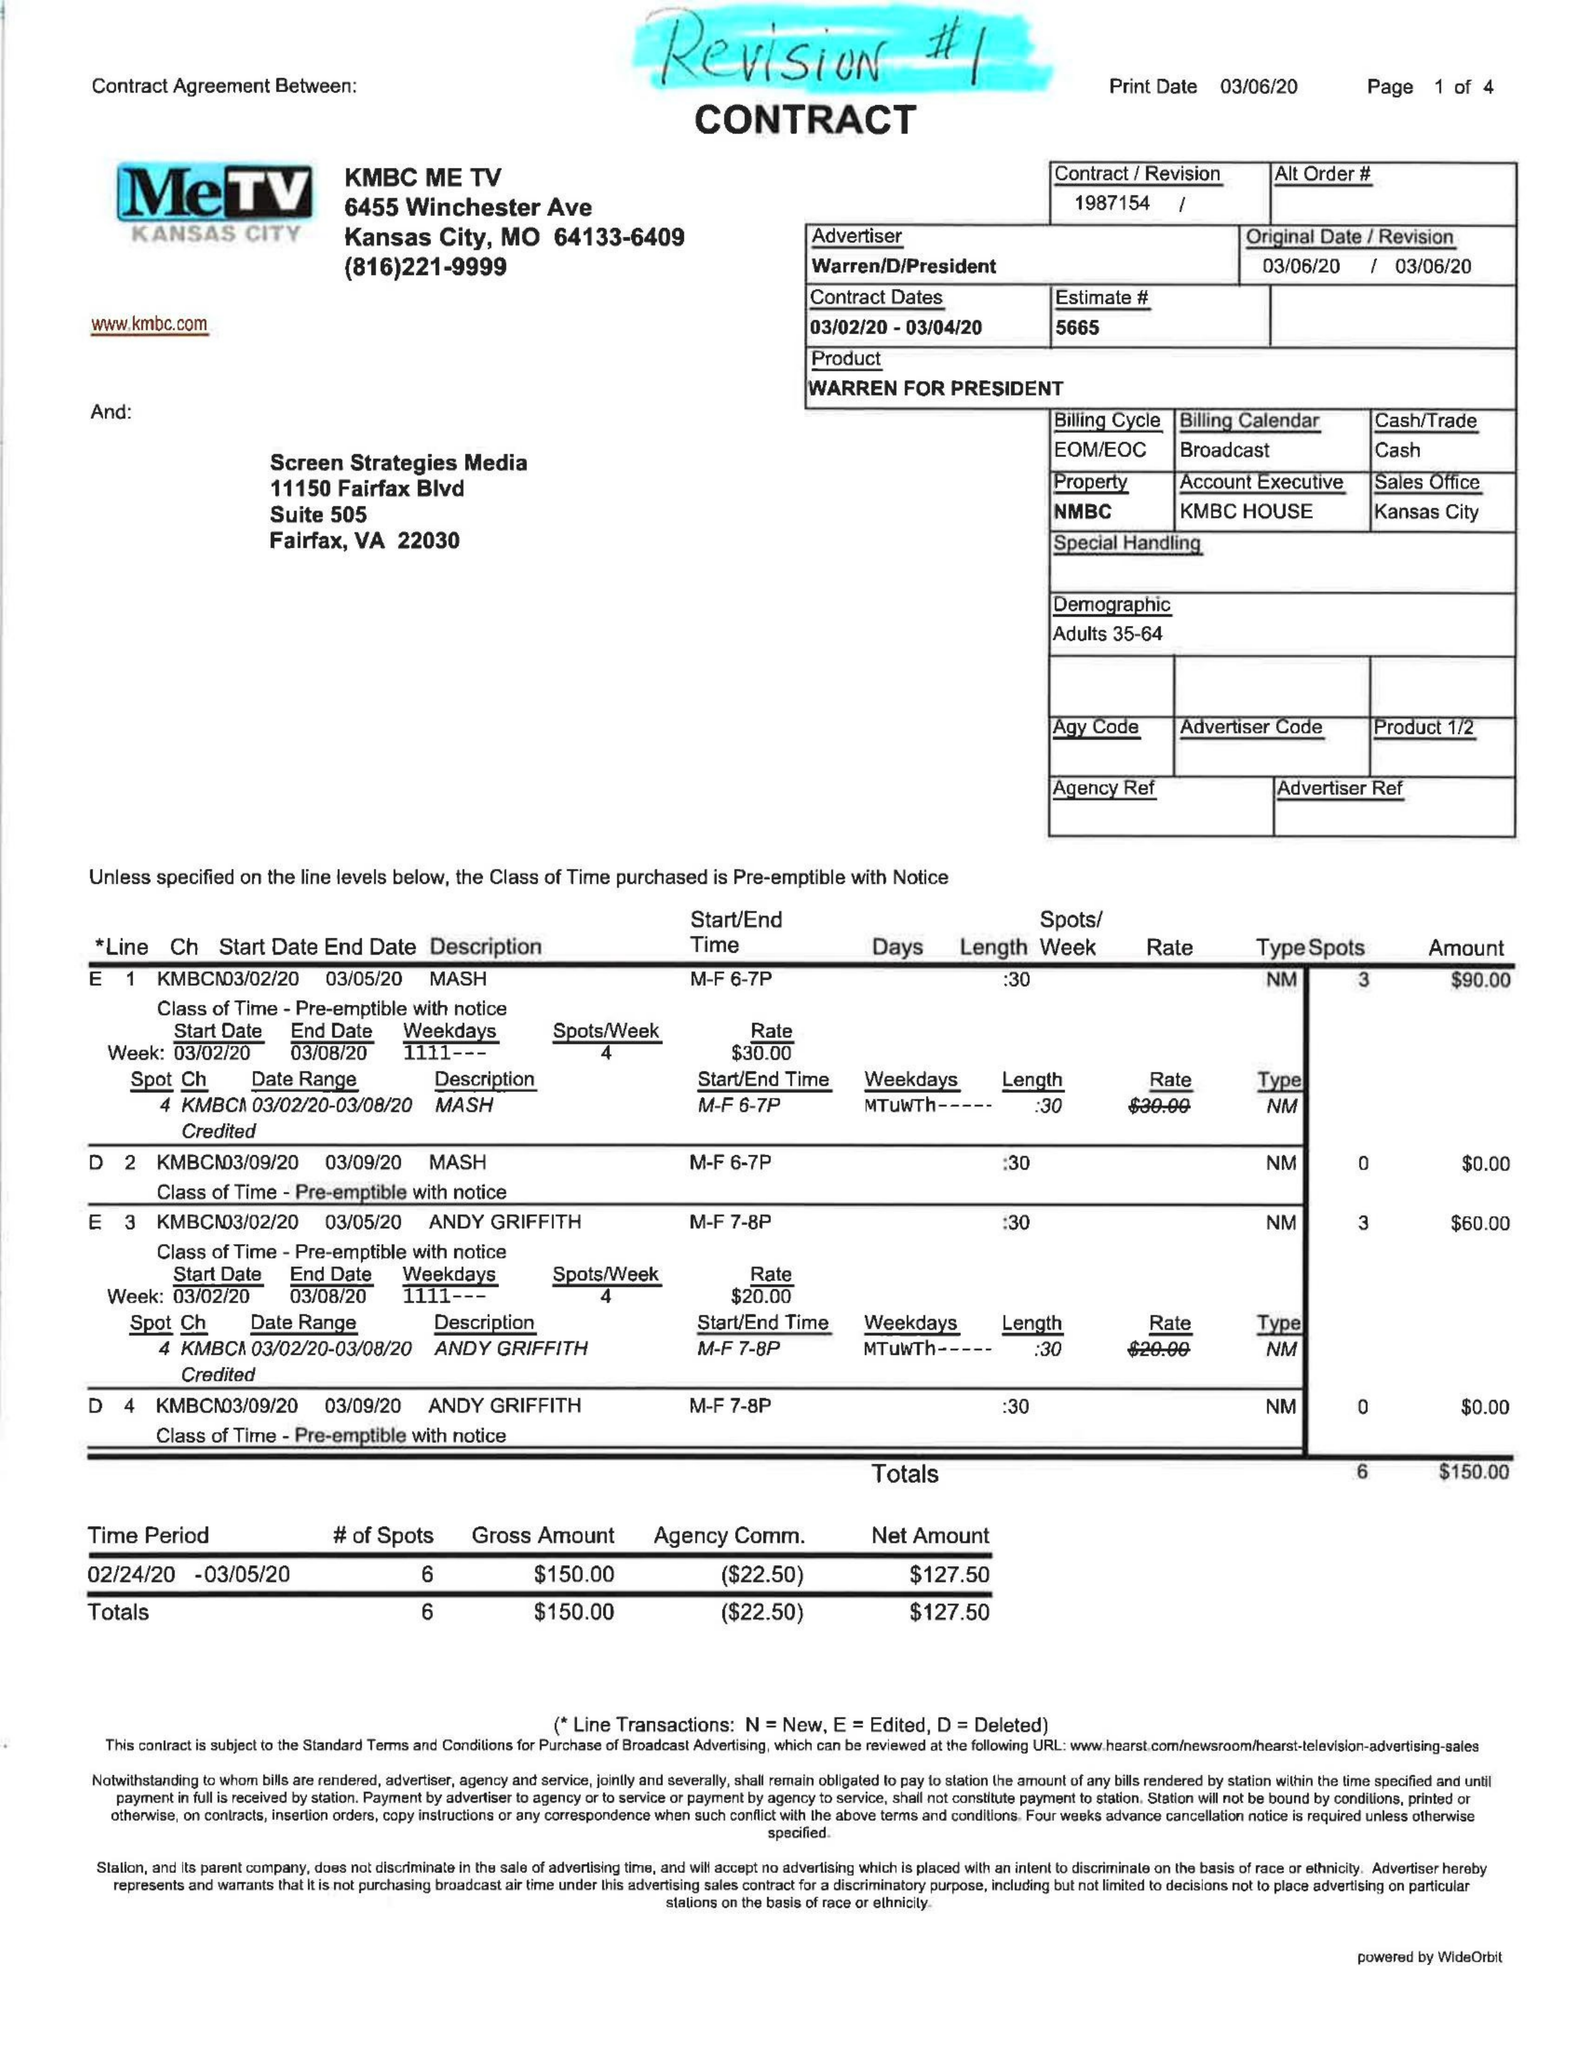What is the value for the flight_to?
Answer the question using a single word or phrase. 03/04/20 